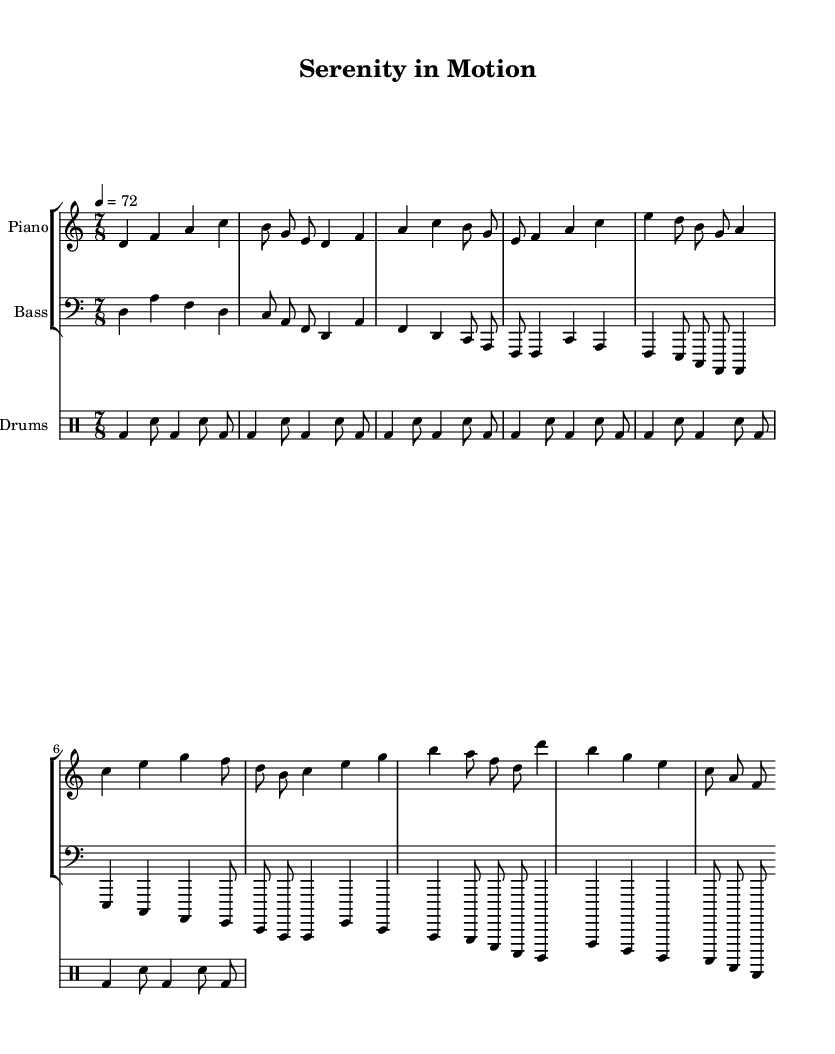What is the key signature of this music? The key signature indicated in the music is Dorian, which is associated with the B minor scale. In traditional notation, Dorian has two sharps: F# and C#.
Answer: D Dorian What is the time signature of this music? The time signature displayed at the beginning is 7/8, indicating there are seven beats in each measure, and the eighth note gets one beat.
Answer: 7/8 What is the tempo marking for this piece? The tempo marking shows "4 = 72," which means that a quarter note is to be played at a speed of 72 beats per minute.
Answer: 72 How many measures are there in the piano part? By counting the distinct groups of notes known as measures in the piano staff, we find there are six complete measures represented in the section shown.
Answer: 6 Which instruments are present in this score? The score includes three distinct instruments indicated at the beginning: Piano, Bass, and Drums, where each instrument has its corresponding staff.
Answer: Piano, Bass, Drums What is the overall style of this piece? The sheet music labels the piece "Serenity in Motion," suggesting a calming and experimental jazz style, indicative of sound therapy for stress relief.
Answer: Experimental jazz 